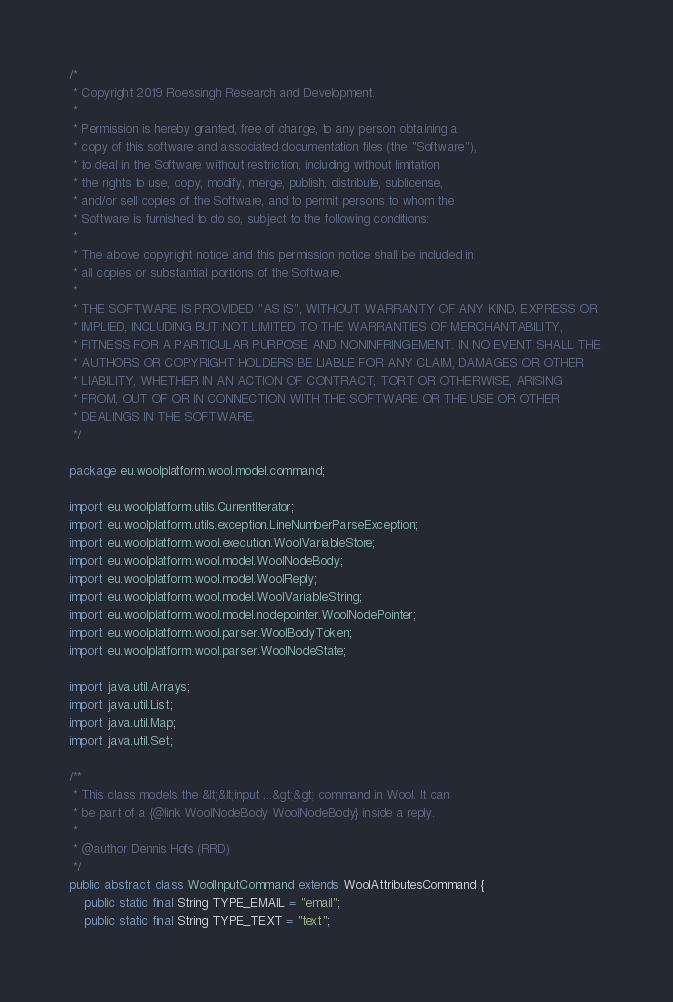<code> <loc_0><loc_0><loc_500><loc_500><_Java_>/*
 * Copyright 2019 Roessingh Research and Development.
 * 
 * Permission is hereby granted, free of charge, to any person obtaining a 
 * copy of this software and associated documentation files (the "Software"), 
 * to deal in the Software without restriction, including without limitation 
 * the rights to use, copy, modify, merge, publish, distribute, sublicense, 
 * and/or sell copies of the Software, and to permit persons to whom the 
 * Software is furnished to do so, subject to the following conditions:
 * 
 * The above copyright notice and this permission notice shall be included in
 * all copies or substantial portions of the Software.
 *
 * THE SOFTWARE IS PROVIDED "AS IS", WITHOUT WARRANTY OF ANY KIND, EXPRESS OR 
 * IMPLIED, INCLUDING BUT NOT LIMITED TO THE WARRANTIES OF MERCHANTABILITY, 
 * FITNESS FOR A PARTICULAR PURPOSE AND NONINFRINGEMENT. IN NO EVENT SHALL THE 
 * AUTHORS OR COPYRIGHT HOLDERS BE LIABLE FOR ANY CLAIM, DAMAGES OR OTHER 
 * LIABILITY, WHETHER IN AN ACTION OF CONTRACT, TORT OR OTHERWISE, ARISING 
 * FROM, OUT OF OR IN CONNECTION WITH THE SOFTWARE OR THE USE OR OTHER 
 * DEALINGS IN THE SOFTWARE.
 */

package eu.woolplatform.wool.model.command;

import eu.woolplatform.utils.CurrentIterator;
import eu.woolplatform.utils.exception.LineNumberParseException;
import eu.woolplatform.wool.execution.WoolVariableStore;
import eu.woolplatform.wool.model.WoolNodeBody;
import eu.woolplatform.wool.model.WoolReply;
import eu.woolplatform.wool.model.WoolVariableString;
import eu.woolplatform.wool.model.nodepointer.WoolNodePointer;
import eu.woolplatform.wool.parser.WoolBodyToken;
import eu.woolplatform.wool.parser.WoolNodeState;

import java.util.Arrays;
import java.util.List;
import java.util.Map;
import java.util.Set;

/**
 * This class models the &lt;&lt;input ...&gt;&gt; command in Wool. It can
 * be part of a {@link WoolNodeBody WoolNodeBody} inside a reply.
 * 
 * @author Dennis Hofs (RRD)
 */
public abstract class WoolInputCommand extends WoolAttributesCommand {
	public static final String TYPE_EMAIL = "email";
	public static final String TYPE_TEXT = "text";</code> 